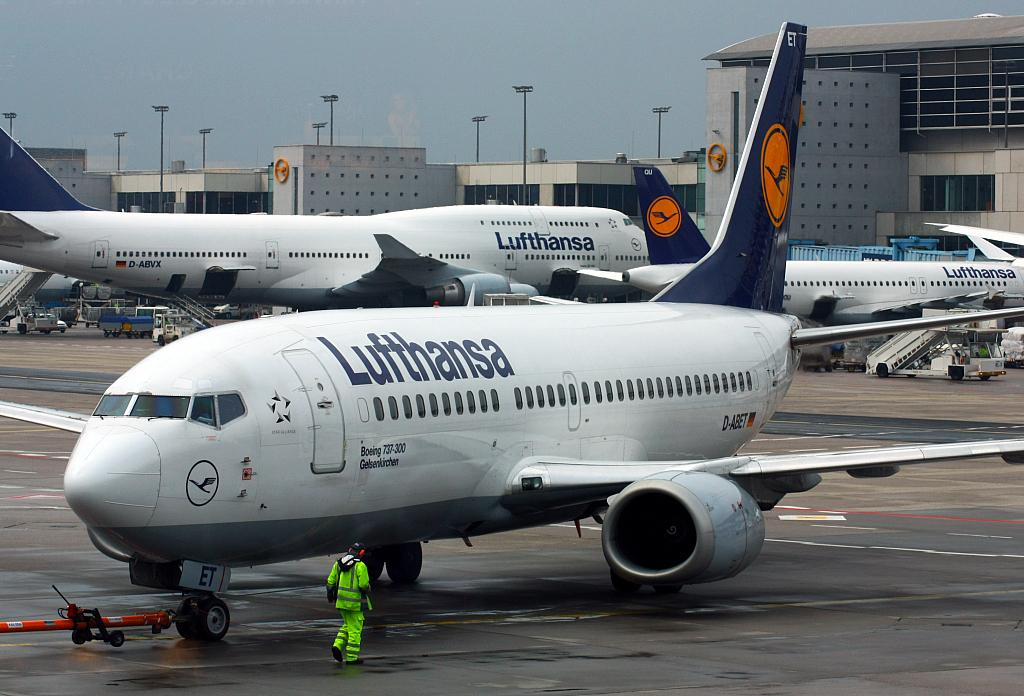Provide a one-sentence caption for the provided image. Lufthansa aircraft sits on the tarmac with three other planes. 